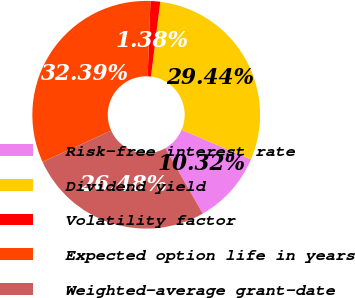Convert chart. <chart><loc_0><loc_0><loc_500><loc_500><pie_chart><fcel>Risk-free interest rate<fcel>Dividend yield<fcel>Volatility factor<fcel>Expected option life in years<fcel>Weighted-average grant-date<nl><fcel>10.32%<fcel>29.44%<fcel>1.38%<fcel>32.39%<fcel>26.48%<nl></chart> 